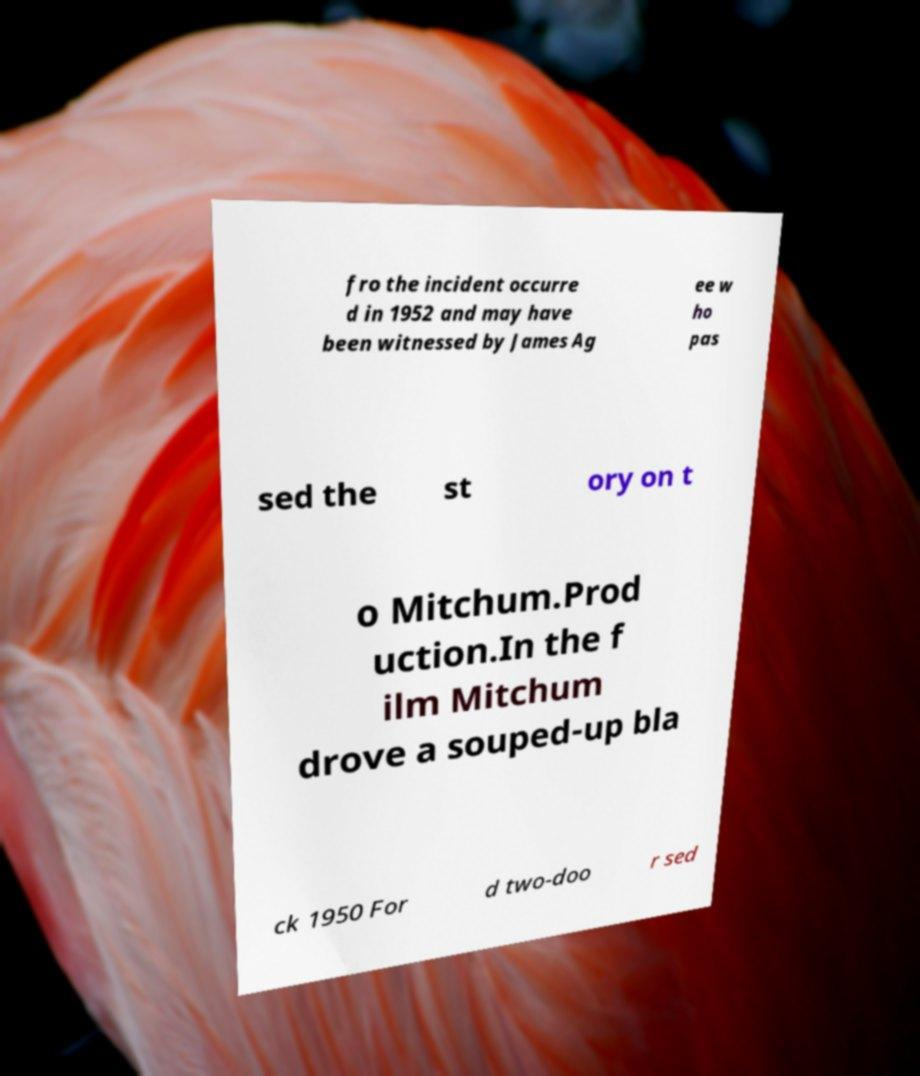There's text embedded in this image that I need extracted. Can you transcribe it verbatim? fro the incident occurre d in 1952 and may have been witnessed by James Ag ee w ho pas sed the st ory on t o Mitchum.Prod uction.In the f ilm Mitchum drove a souped-up bla ck 1950 For d two-doo r sed 